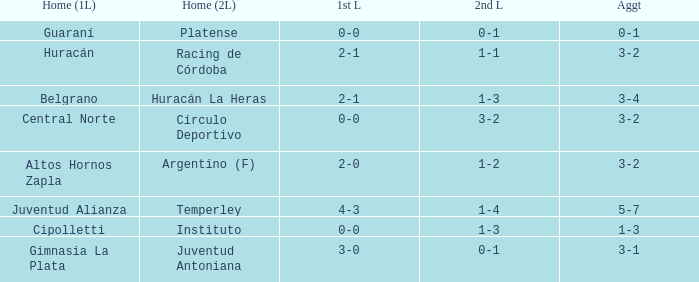Which team played the 2nd leg at home with a tie of 1-1 and scored 3-2 in aggregate? Racing de Córdoba. 